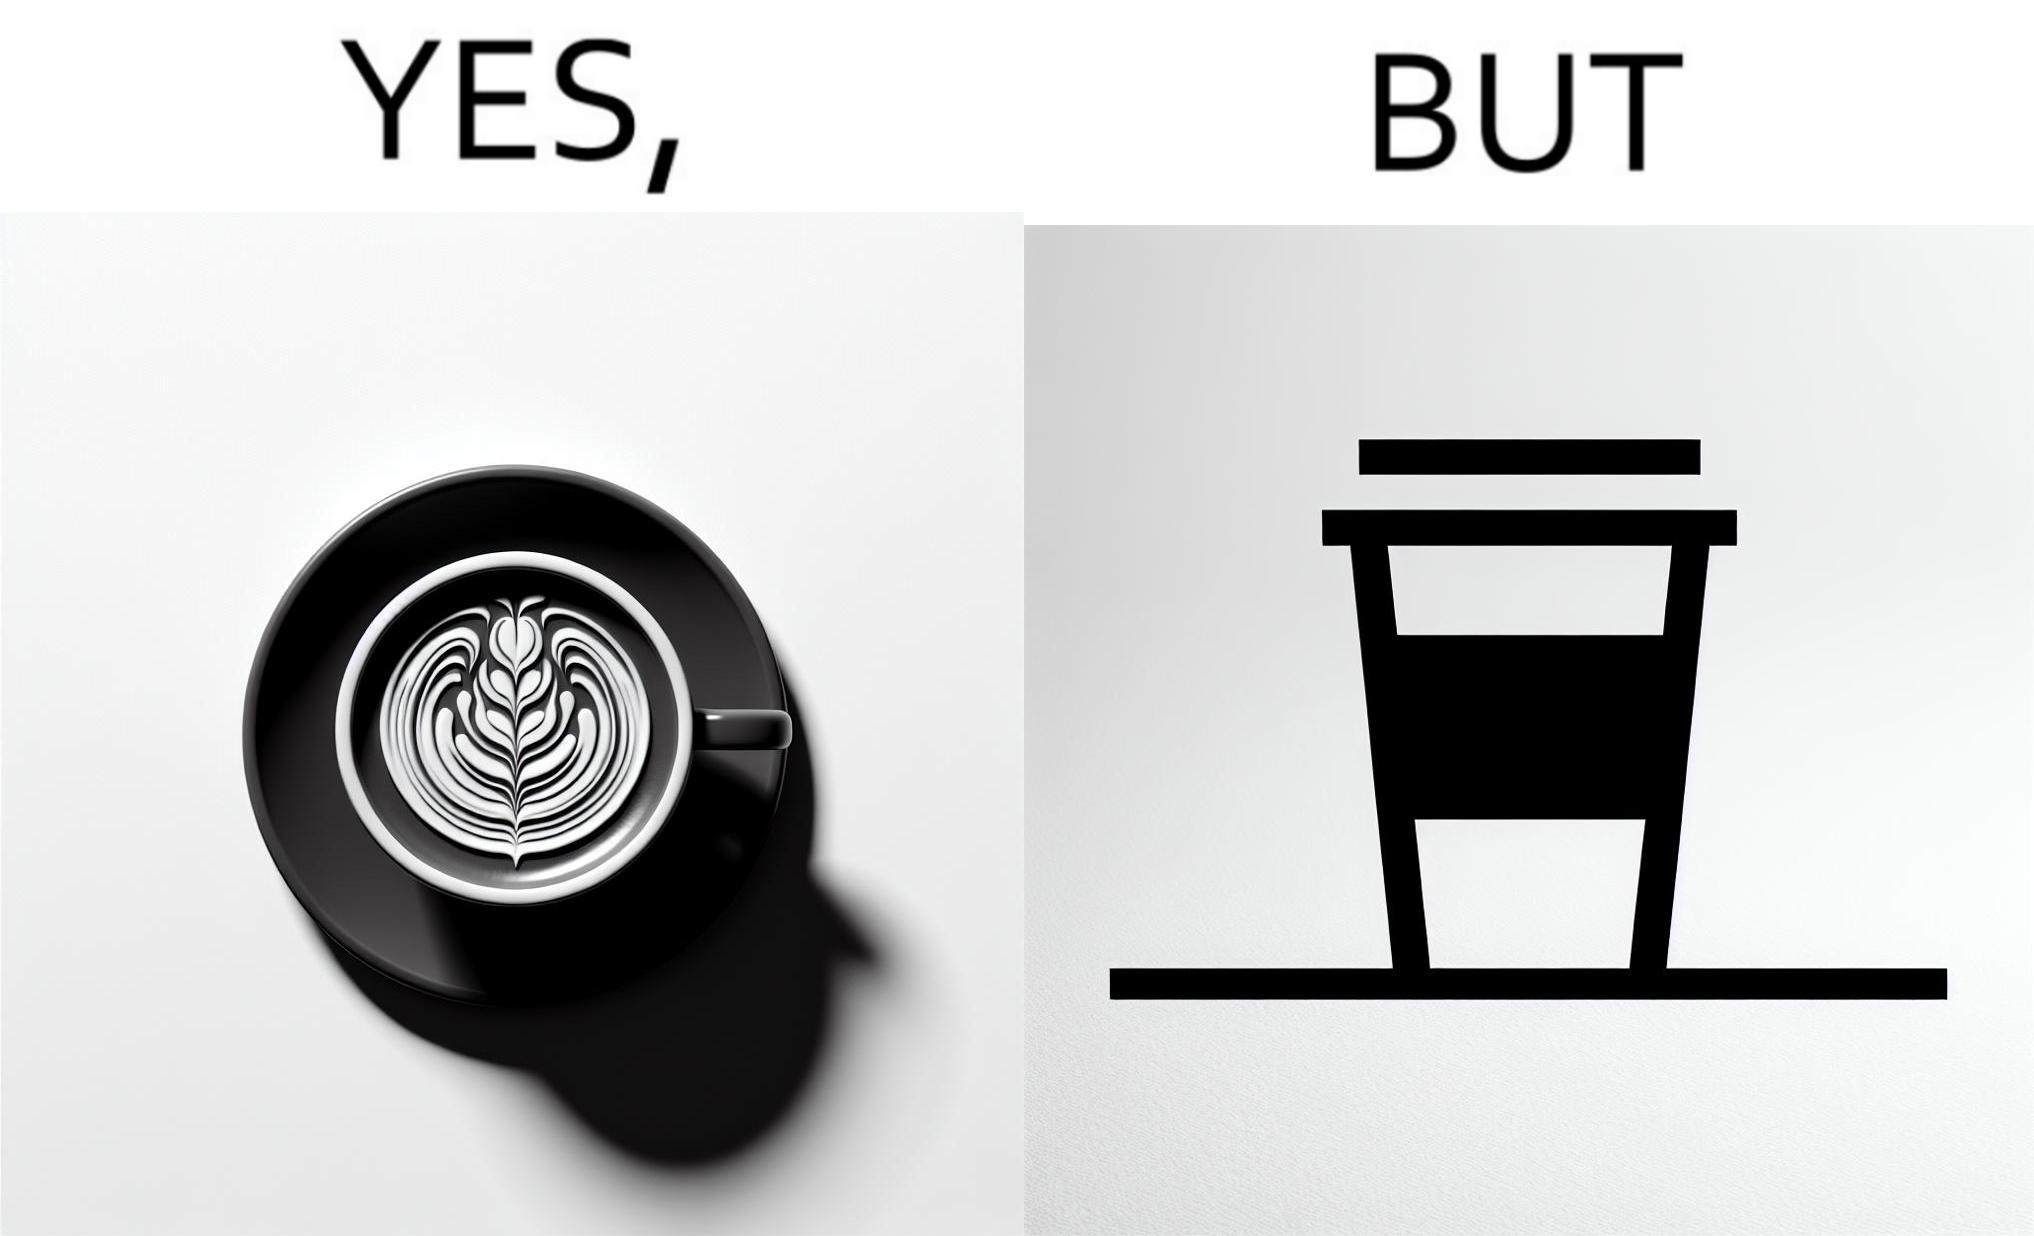What makes this image funny or satirical? The images are funny since it shows how someone has put effort into a cup of coffee to do latte art on it only for it to be invisible after a lid is put on the coffee cup before serving to a customer 